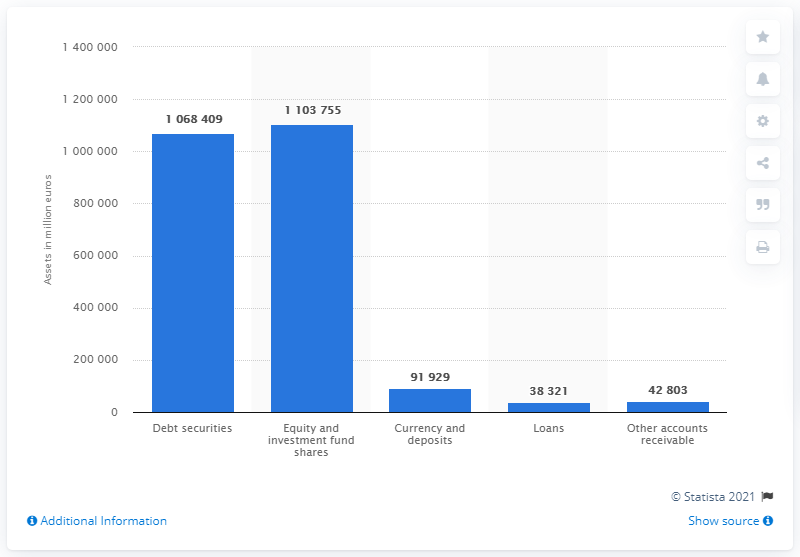Specify some key components in this picture. In 2019, the total financial assets of investment funds held in debt securities in Germany were valued at 110,375,500 units. The total value of equity and investment fund shares owned by investment funds in Germany in 2019 was 110,375,500. 